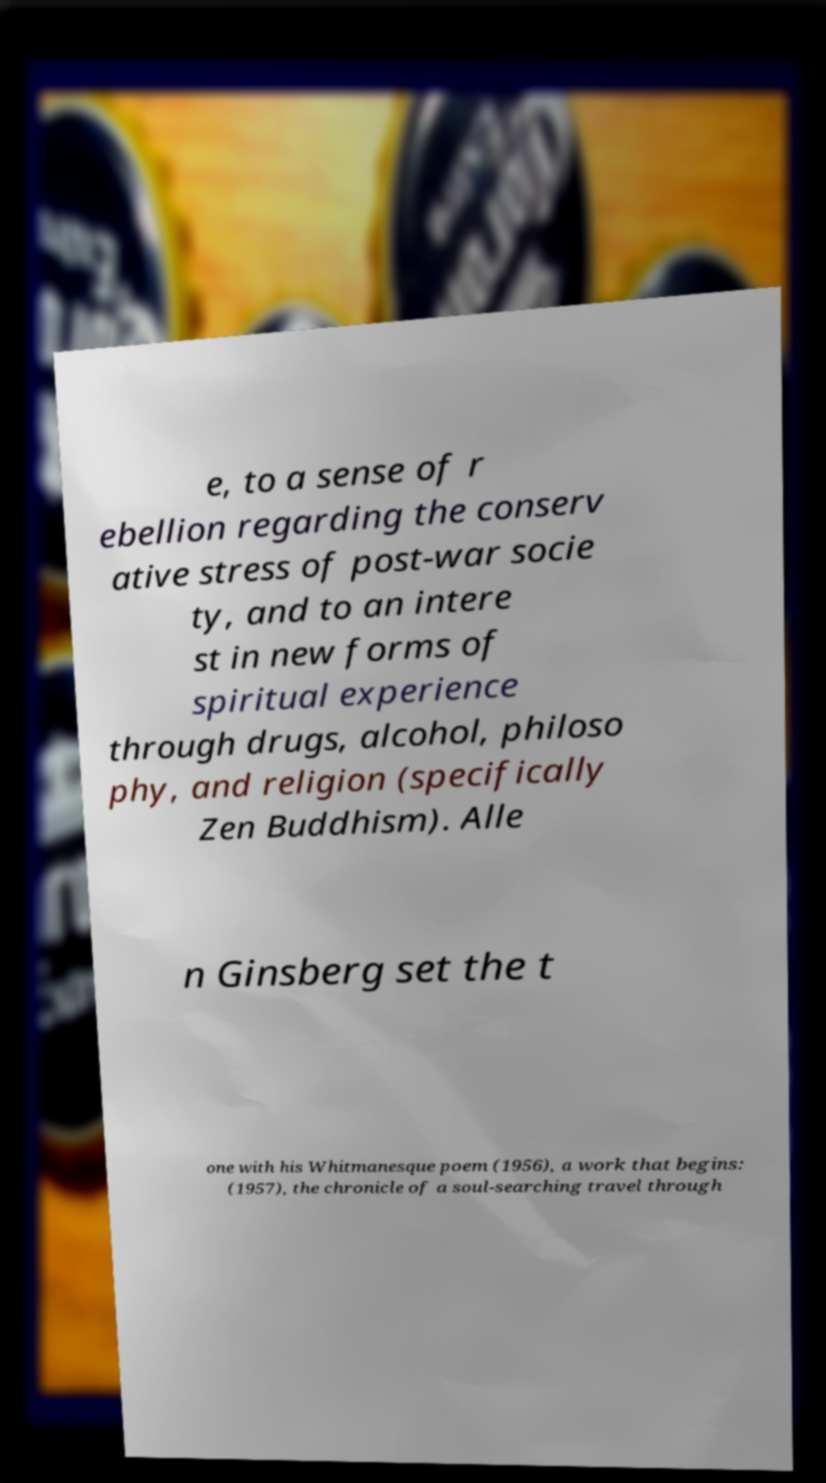For documentation purposes, I need the text within this image transcribed. Could you provide that? e, to a sense of r ebellion regarding the conserv ative stress of post-war socie ty, and to an intere st in new forms of spiritual experience through drugs, alcohol, philoso phy, and religion (specifically Zen Buddhism). Alle n Ginsberg set the t one with his Whitmanesque poem (1956), a work that begins: (1957), the chronicle of a soul-searching travel through 